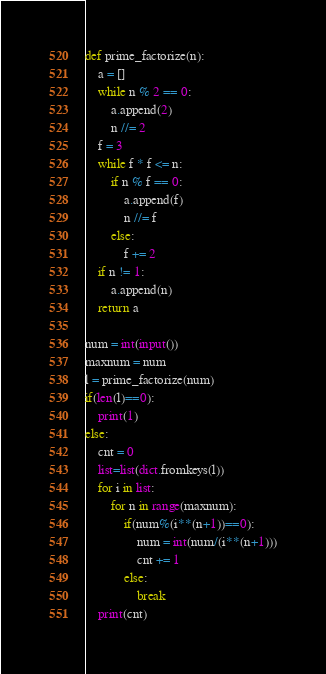Convert code to text. <code><loc_0><loc_0><loc_500><loc_500><_Python_>def prime_factorize(n):
    a = []
    while n % 2 == 0:
        a.append(2)
        n //= 2
    f = 3
    while f * f <= n:
        if n % f == 0:
            a.append(f)
            n //= f
        else:
            f += 2
    if n != 1:
        a.append(n)
    return a

num = int(input())
maxnum = num
l = prime_factorize(num)
if(len(l)==0):
    print(1)
else:
    cnt = 0
    list=list(dict.fromkeys(l))
    for i in list:
        for n in range(maxnum):
            if(num%(i**(n+1))==0):
                num = int(num/(i**(n+1)))
                cnt += 1
            else:
                break
    print(cnt)
</code> 